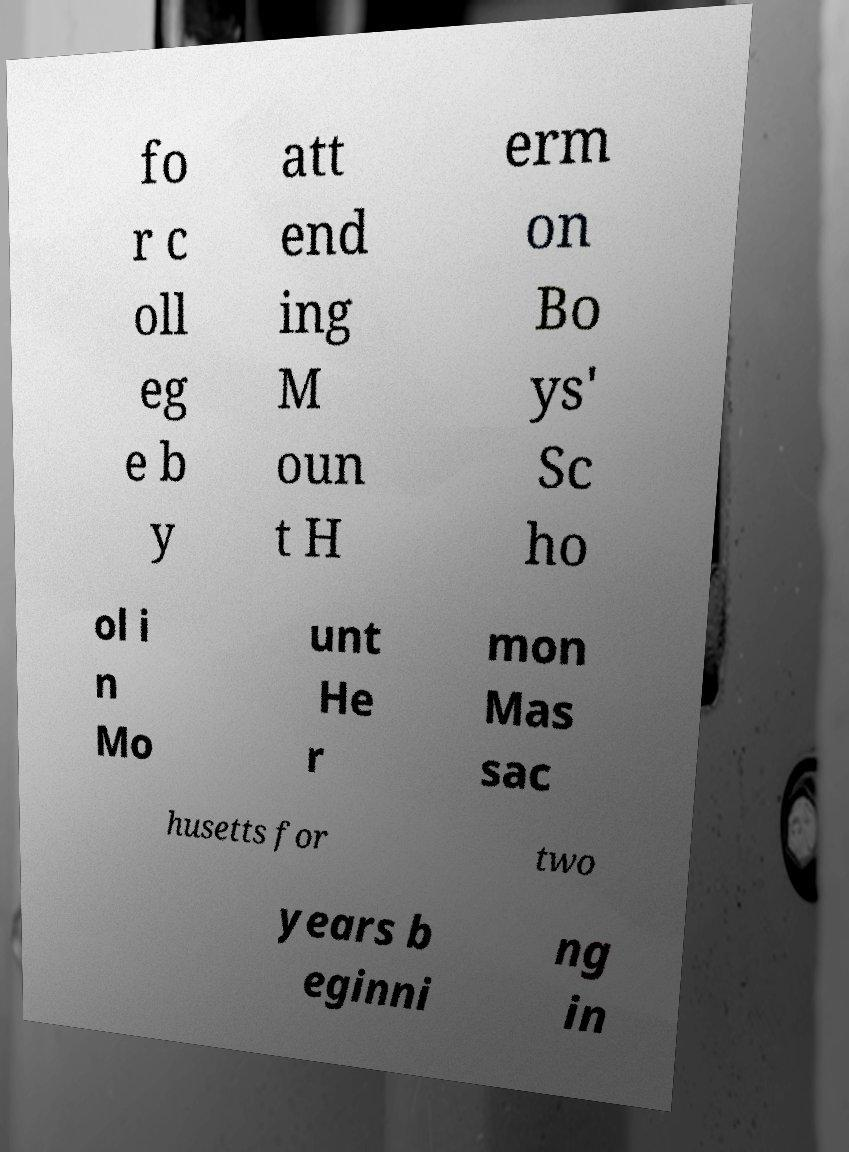Please identify and transcribe the text found in this image. fo r c oll eg e b y att end ing M oun t H erm on Bo ys' Sc ho ol i n Mo unt He r mon Mas sac husetts for two years b eginni ng in 